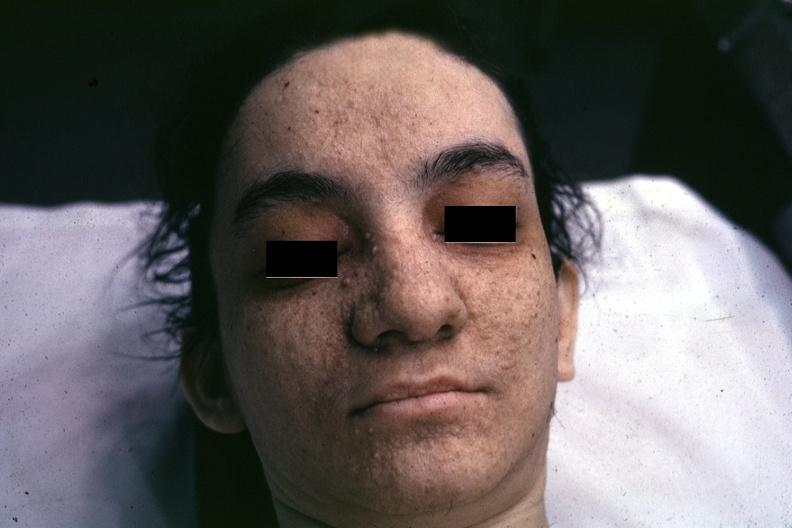what is very good example associated?
Answer the question using a single word or phrase. With tuberous sclerosis 